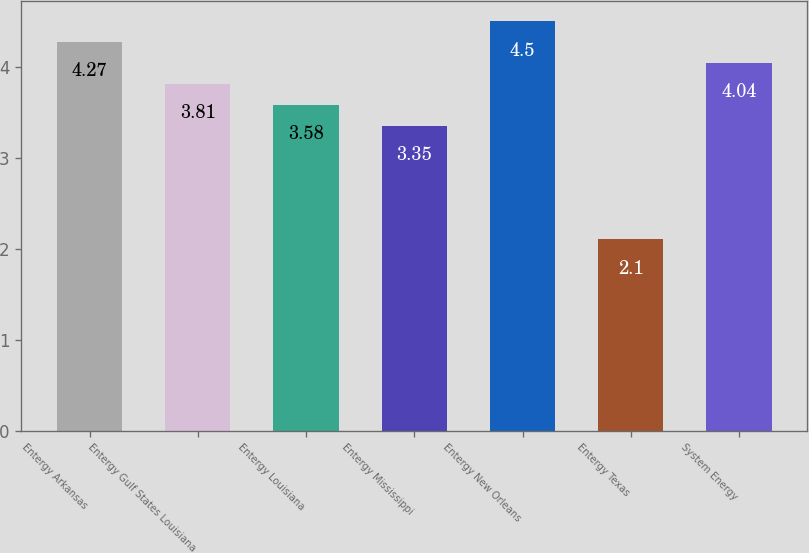Convert chart to OTSL. <chart><loc_0><loc_0><loc_500><loc_500><bar_chart><fcel>Entergy Arkansas<fcel>Entergy Gulf States Louisiana<fcel>Entergy Louisiana<fcel>Entergy Mississippi<fcel>Entergy New Orleans<fcel>Entergy Texas<fcel>System Energy<nl><fcel>4.27<fcel>3.81<fcel>3.58<fcel>3.35<fcel>4.5<fcel>2.1<fcel>4.04<nl></chart> 